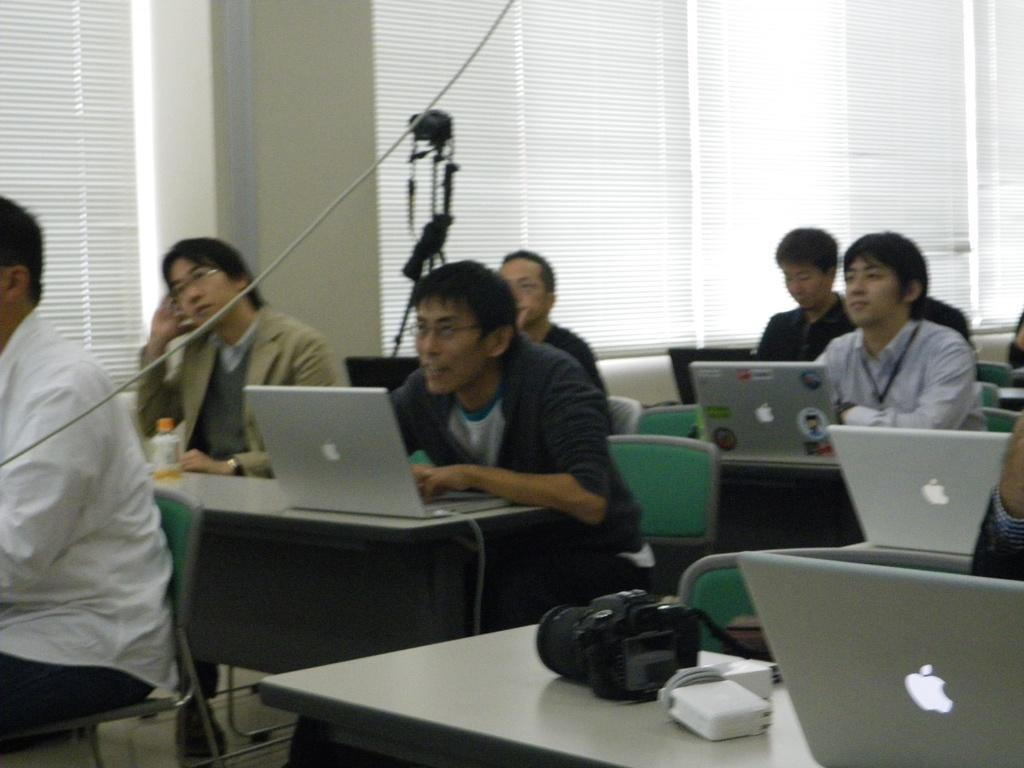How many people are in the image? There is a group of people in the image. What are the people doing in the image? The people are sitting on a chair and working on laptops. What can be seen in the background of the image? There is a camera, a window, and a wall in the background of the image. What type of sweater is the writer wearing in the image? There is no writer or sweater present in the image. The people in the image are working on laptops, not writing. 